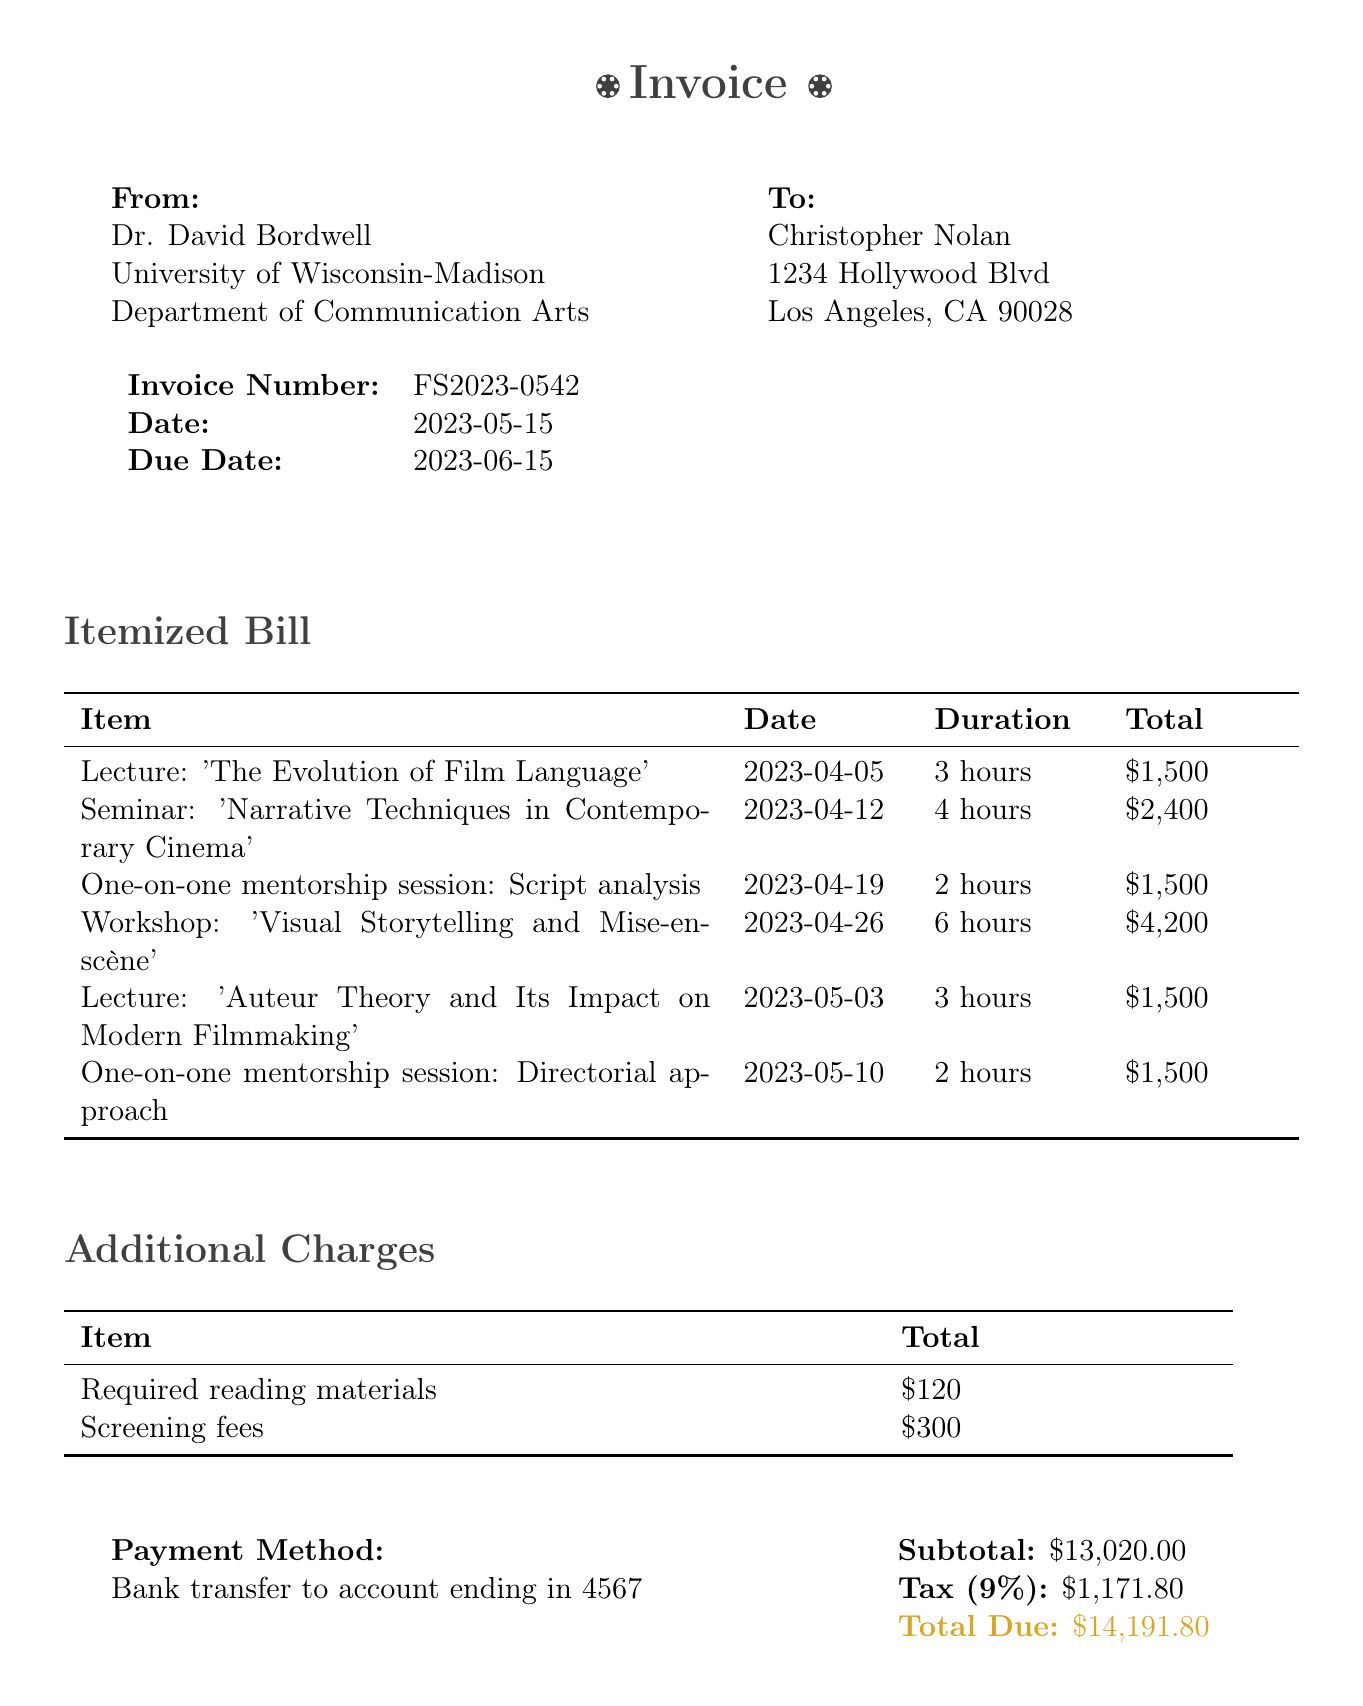What is the invoice number? The invoice number is specified at the beginning of the document under invoice details.
Answer: FS2023-0542 Who is the client? The client's name is mentioned in the 'To' section of the invoice.
Answer: Christopher Nolan What is the due date for the invoice? The due date is listed under invoice details and specifies when the payment is due.
Answer: 2023-06-15 How much is the subtotal before tax? The subtotal is the sum of the itemized bill and additional charges before tax is applied.
Answer: $13,020 What was the total charge for the workshop? The total charge for the workshop is provided in the itemized bill section.
Answer: $4,200 How many hours did the seminar last? The duration for the seminar is detailed in the itemized bill section.
Answer: 4 hours What is the total due amount? The total due is calculated by adding the subtotal and taxes, and is listed at the end of the invoice.
Answer: $14,191.80 What method of payment is specified? The payment method is mentioned in the payment info section of the document.
Answer: Bank transfer to account ending in 4567 What additional charges were incurred? The additional charges are listed in a specific section detailing each charge.
Answer: $120 (required reading materials) and $300 (screening fees) 